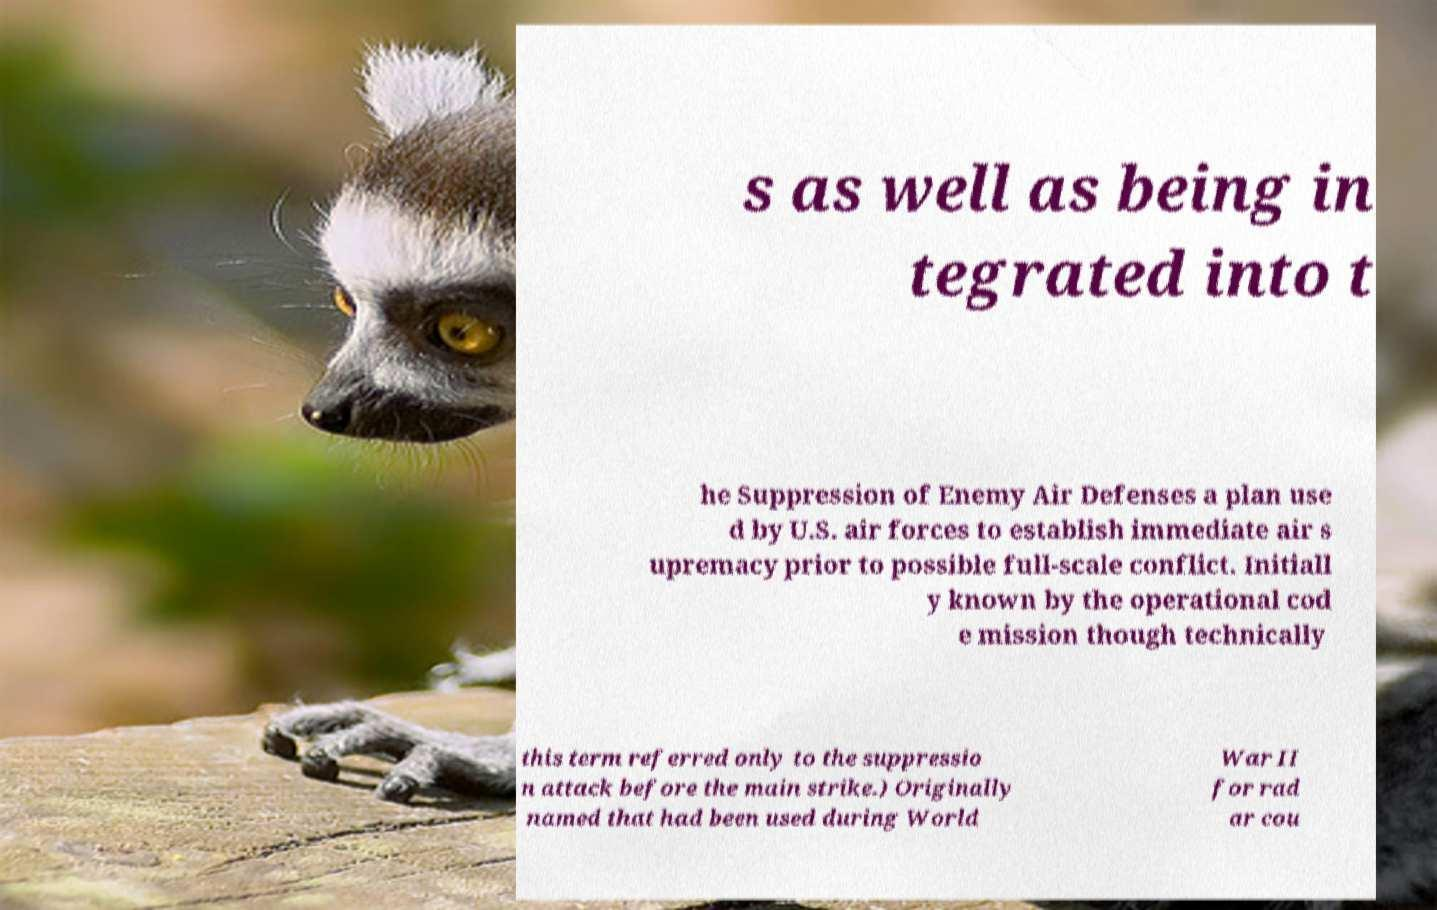I need the written content from this picture converted into text. Can you do that? s as well as being in tegrated into t he Suppression of Enemy Air Defenses a plan use d by U.S. air forces to establish immediate air s upremacy prior to possible full-scale conflict. Initiall y known by the operational cod e mission though technically this term referred only to the suppressio n attack before the main strike.) Originally named that had been used during World War II for rad ar cou 